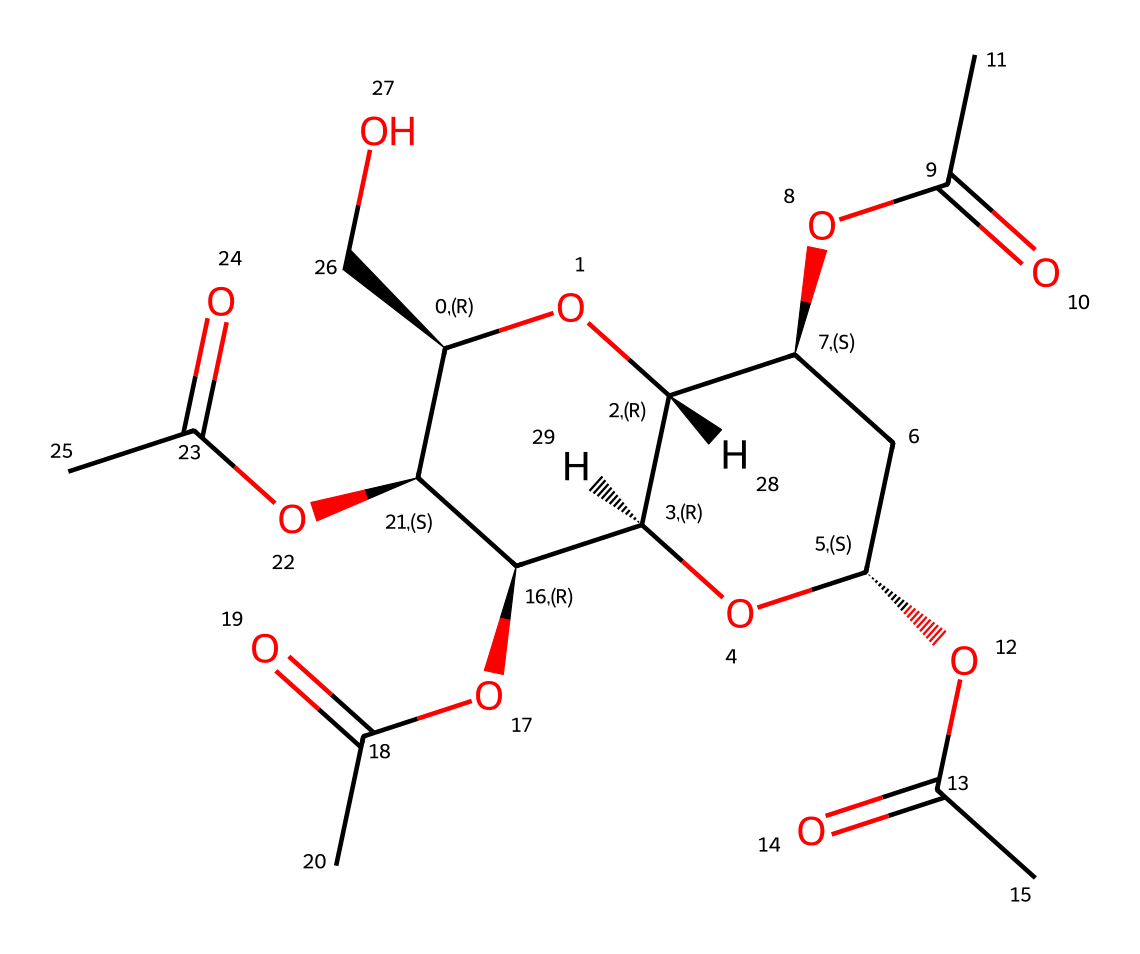What is the primary functional group present in cellulose acetate? The structure contains multiple ester linkages, which arise from the acetylation of the hydroxyl groups of cellulose. The presence of these ester bonds characterizes cellulose acetate.
Answer: ester How many carbons are present in the main structure of cellulose acetate? Counting the carbon atoms in the SMILES representation, we see that there are 12 carbon atoms in the backbone structure of cellulose acetate.
Answer: 12 What type of polymer is cellulose acetate classified as? Cellulose acetate is classified as a thermoplastic polymer, which means it's a polymer that becomes pliable or moldable upon heating.
Answer: thermoplastic What impact do the acetyl groups have on cellulose acetate’s solubility? The presence of acetyl groups increases the hydrophobic character of cellulose acetate, making it less soluble in water compared to cellulose.
Answer: hydrophobic How does the presence of the acetyl groups affect the rigidity of cellulose acetate? Acetyl groups introduce steric bulk and disrupt intermolecular hydrogen bonding, thus reducing flexibility and increasing stiffness compared to unmodified cellulose.
Answer: rigidity In the context of photography, why is cellulose acetate used as a film base? Cellulose acetate offers several advantages such as transparency, flexibility, and stability under varying environmental conditions, making it a preferred choice for photographic films.
Answer: stability 